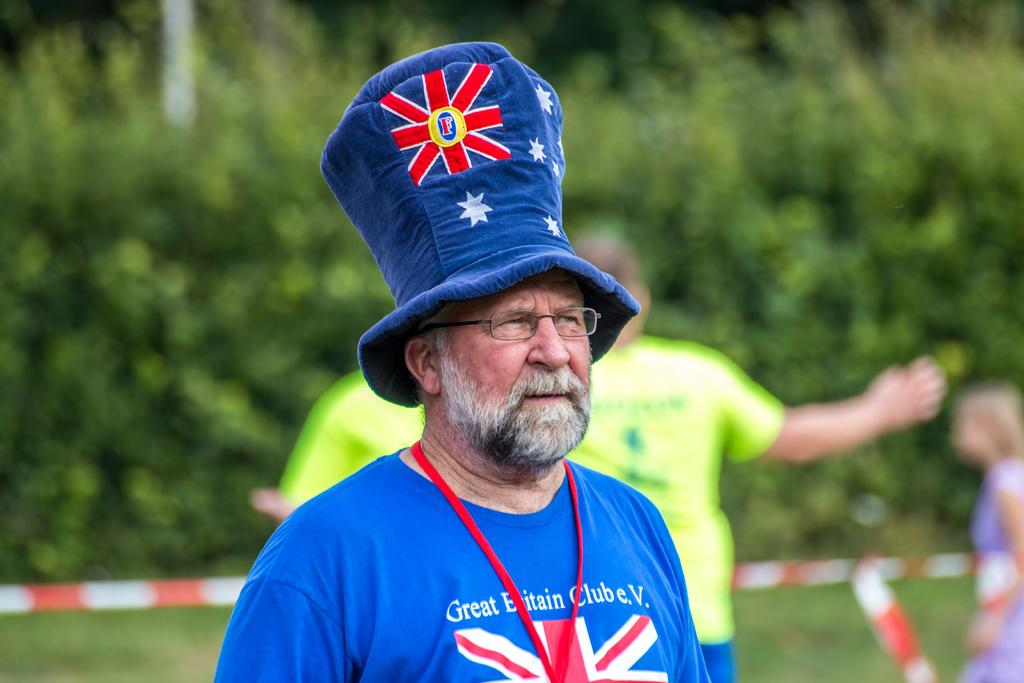<image>
Share a concise interpretation of the image provided. A man with a beard wears a tall hat with the Unin Jack on it and a T shirt to match which says Great Britain Club e.v 